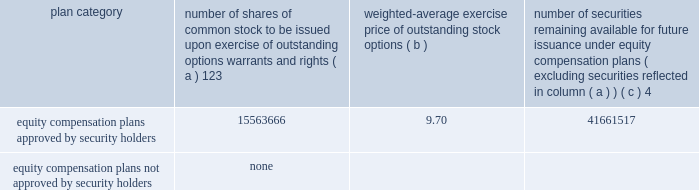Part iii item 10 .
Directors , executive officers and corporate governance the information required by this item is incorporated by reference to the 201celection of directors 201d section , the 201cdirector selection process 201d section , the 201ccode of conduct 201d section , the 201cprincipal committees of the board of directors 201d section , the 201caudit committee 201d section and the 201csection 16 ( a ) beneficial ownership reporting compliance 201d section of the proxy statement for the annual meeting of stockholders to be held on may 21 , 2015 ( the 201cproxy statement 201d ) , except for the description of our executive officers , which appears in part i of this report on form 10-k under the heading 201cexecutive officers of ipg . 201d new york stock exchange certification in 2014 , our chief executive officer provided the annual ceo certification to the new york stock exchange , as required under section 303a.12 ( a ) of the new york stock exchange listed company manual .
Item 11 .
Executive compensation the information required by this item is incorporated by reference to the 201cexecutive compensation 201d section , the 201cnon- management director compensation 201d section , the 201ccompensation discussion and analysis 201d section and the 201ccompensation and leadership talent committee report 201d section of the proxy statement .
Item 12 .
Security ownership of certain beneficial owners and management and related stockholder matters the information required by this item is incorporated by reference to the 201coutstanding shares and ownership of common stock 201d section of the proxy statement , except for information regarding the shares of common stock to be issued or which may be issued under our equity compensation plans as of december 31 , 2014 , which is provided in the table .
Equity compensation plan information plan category number of shares of common stock to be issued upon exercise of outstanding options , warrants and rights ( a ) 123 weighted-average exercise price of outstanding stock options number of securities remaining available for future issuance under equity compensation plans ( excluding securities reflected in column ( a ) ) equity compensation plans approved by security holders .
15563666 9.70 41661517 equity compensation plans not approved by security holders .
None 1 included a total of 5866475 performance-based share awards made under the 2009 and 2014 performance incentive plans representing the target number of shares of common stock to be issued to employees following the completion of the 2012-2014 performance period ( the 201c2014 ltip share awards 201d ) , the 2013-2015 performance period ( the 201c2015 ltip share awards 201d ) and the 2014-2016 performance period ( the 201c2016 ltip share awards 201d ) , respectively .
The computation of the weighted-average exercise price in column ( b ) of this table does not take the 2014 ltip share awards , the 2015 ltip share awards or the 2016 ltip share awards into account .
2 included a total of 98877 restricted share units and performance-based awards ( 201cshare unit awards 201d ) which may be settled in shares of common stock or cash .
The computation of the weighted-average exercise price in column ( b ) of this table does not take the share unit awards into account .
Each share unit award actually settled in cash will increase the number of shares of common stock available for issuance shown in column ( c ) .
3 ipg has issued restricted cash awards ( 201cperformance cash awards 201d ) , half of which shall be settled in shares of common stock and half of which shall be settled in cash .
Using the 2014 closing stock price of $ 20.77 , the awards which shall be settled in shares of common stock represent rights to an additional 2721405 shares .
These shares are not included in the table above .
4 included ( i ) 29045044 shares of common stock available for issuance under the 2014 performance incentive plan , ( ii ) 12181214 shares of common stock available for issuance under the employee stock purchase plan ( 2006 ) and ( iii ) 435259 shares of common stock available for issuance under the 2009 non-management directors 2019 stock incentive plan. .
Part iii item 10 .
Directors , executive officers and corporate governance the information required by this item is incorporated by reference to the 201celection of directors 201d section , the 201cdirector selection process 201d section , the 201ccode of conduct 201d section , the 201cprincipal committees of the board of directors 201d section , the 201caudit committee 201d section and the 201csection 16 ( a ) beneficial ownership reporting compliance 201d section of the proxy statement for the annual meeting of stockholders to be held on may 21 , 2015 ( the 201cproxy statement 201d ) , except for the description of our executive officers , which appears in part i of this report on form 10-k under the heading 201cexecutive officers of ipg . 201d new york stock exchange certification in 2014 , our chief executive officer provided the annual ceo certification to the new york stock exchange , as required under section 303a.12 ( a ) of the new york stock exchange listed company manual .
Item 11 .
Executive compensation the information required by this item is incorporated by reference to the 201cexecutive compensation 201d section , the 201cnon- management director compensation 201d section , the 201ccompensation discussion and analysis 201d section and the 201ccompensation and leadership talent committee report 201d section of the proxy statement .
Item 12 .
Security ownership of certain beneficial owners and management and related stockholder matters the information required by this item is incorporated by reference to the 201coutstanding shares and ownership of common stock 201d section of the proxy statement , except for information regarding the shares of common stock to be issued or which may be issued under our equity compensation plans as of december 31 , 2014 , which is provided in the following table .
Equity compensation plan information plan category number of shares of common stock to be issued upon exercise of outstanding options , warrants and rights ( a ) 123 weighted-average exercise price of outstanding stock options number of securities remaining available for future issuance under equity compensation plans ( excluding securities reflected in column ( a ) ) equity compensation plans approved by security holders .
15563666 9.70 41661517 equity compensation plans not approved by security holders .
None 1 included a total of 5866475 performance-based share awards made under the 2009 and 2014 performance incentive plans representing the target number of shares of common stock to be issued to employees following the completion of the 2012-2014 performance period ( the 201c2014 ltip share awards 201d ) , the 2013-2015 performance period ( the 201c2015 ltip share awards 201d ) and the 2014-2016 performance period ( the 201c2016 ltip share awards 201d ) , respectively .
The computation of the weighted-average exercise price in column ( b ) of this table does not take the 2014 ltip share awards , the 2015 ltip share awards or the 2016 ltip share awards into account .
2 included a total of 98877 restricted share units and performance-based awards ( 201cshare unit awards 201d ) which may be settled in shares of common stock or cash .
The computation of the weighted-average exercise price in column ( b ) of this table does not take the share unit awards into account .
Each share unit award actually settled in cash will increase the number of shares of common stock available for issuance shown in column ( c ) .
3 ipg has issued restricted cash awards ( 201cperformance cash awards 201d ) , half of which shall be settled in shares of common stock and half of which shall be settled in cash .
Using the 2014 closing stock price of $ 20.77 , the awards which shall be settled in shares of common stock represent rights to an additional 2721405 shares .
These shares are not included in the table above .
4 included ( i ) 29045044 shares of common stock available for issuance under the 2014 performance incentive plan , ( ii ) 12181214 shares of common stock available for issuance under the employee stock purchase plan ( 2006 ) and ( iii ) 435259 shares of common stock available for issuance under the 2009 non-management directors 2019 stock incentive plan. .
How many combined shares are available under the 2014 incentive plan , the 2009 incentive plan and the 2006 employee stock purchase plan combined? 
Computations: ((29045044 + 12181214) + 435259)
Answer: 41661517.0. 